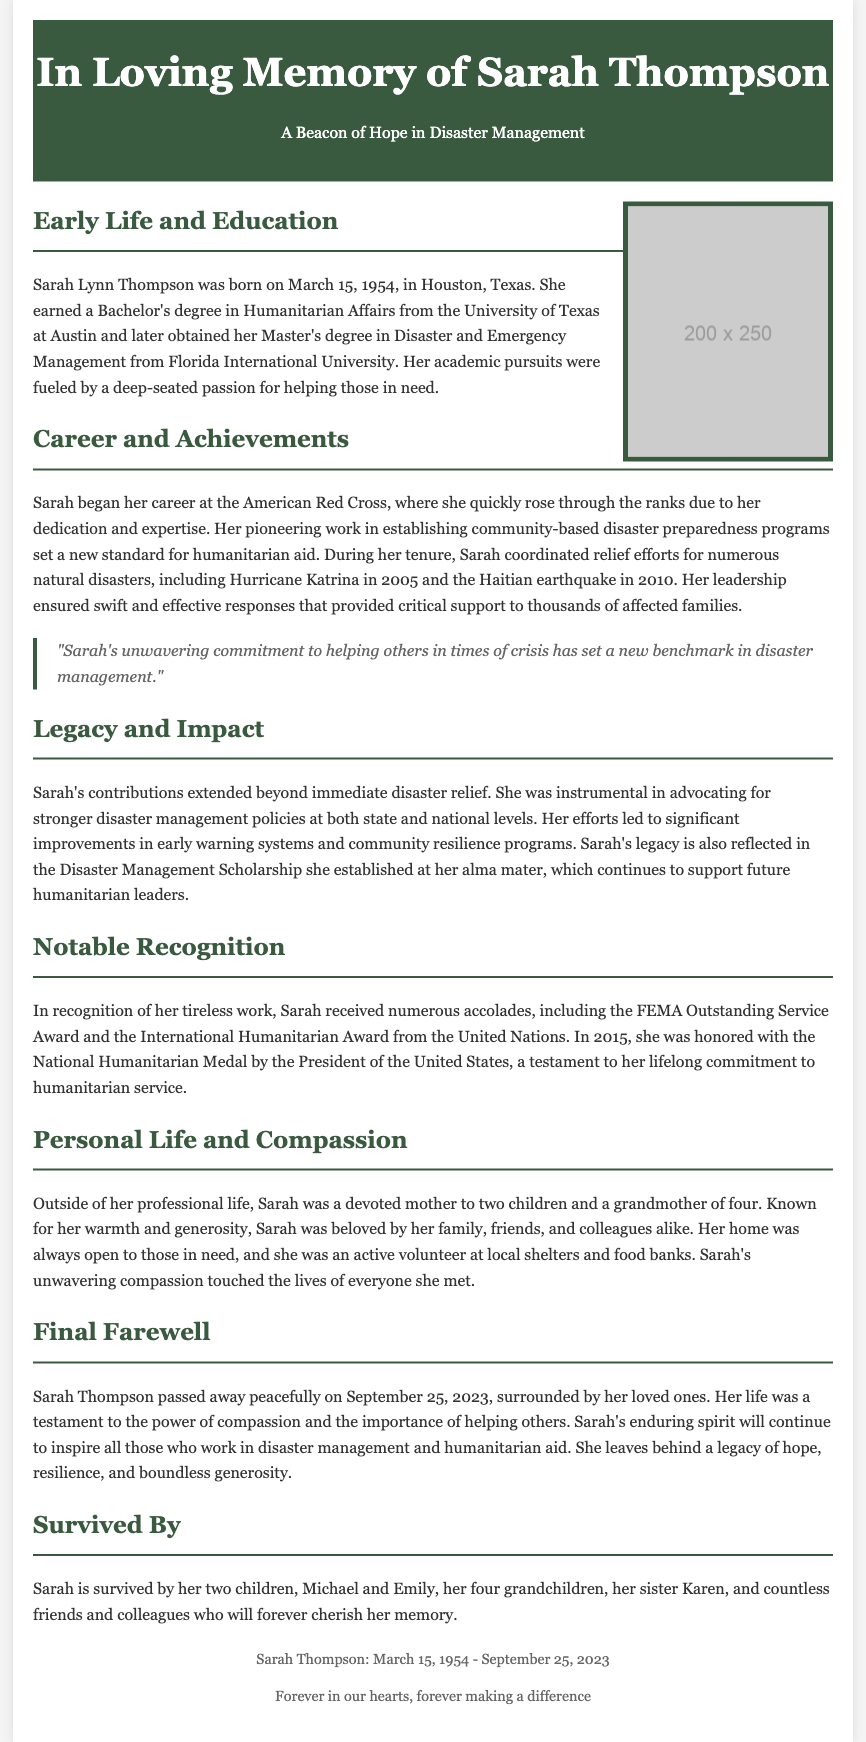what is the full name of the humanitarian? The document states her full name as Sarah Lynn Thompson.
Answer: Sarah Lynn Thompson when was Sarah Thompson born? The document mentions Sarah's birth date as March 15, 1954.
Answer: March 15, 1954 what degrees did Sarah Thompson earn? The document lists her degrees as a Bachelor's in Humanitarian Affairs and a Master's in Disaster and Emergency Management.
Answer: Bachelor's in Humanitarian Affairs, Master's in Disaster and Emergency Management which major disasters did Sarah coordinate relief efforts for? The document refers to Hurricane Katrina in 2005 and the Haitian earthquake in 2010.
Answer: Hurricane Katrina, Haitian earthquake what significant award did Sarah receive in 2015? The document mentions that she was honored with the National Humanitarian Medal by the President of the United States in 2015.
Answer: National Humanitarian Medal how many children did Sarah have? The document states that Sarah was a devoted mother to two children.
Answer: Two what was one of Sarah's impacts on disaster management policy? The document notes that she was instrumental in advocating for stronger disaster management policies.
Answer: Stronger disaster management policies what personal qualities made Sarah beloved by those around her? The document describes her as warm and generous, contributing to her being beloved by family, friends, and colleagues.
Answer: Warmth and generosity 